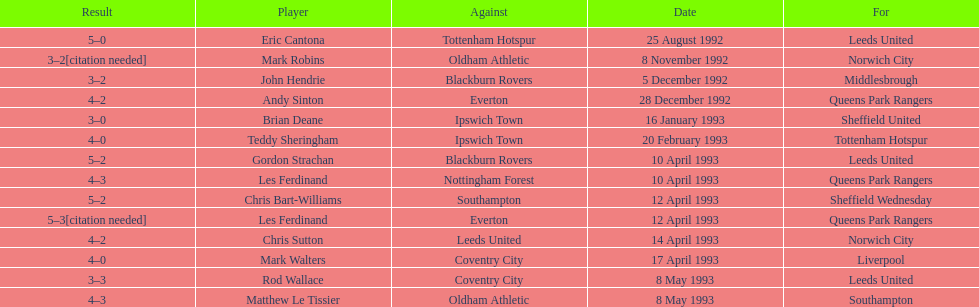Write the full table. {'header': ['Result', 'Player', 'Against', 'Date', 'For'], 'rows': [['5–0', 'Eric Cantona', 'Tottenham Hotspur', '25 August 1992', 'Leeds United'], ['3–2[citation needed]', 'Mark Robins', 'Oldham Athletic', '8 November 1992', 'Norwich City'], ['3–2', 'John Hendrie', 'Blackburn Rovers', '5 December 1992', 'Middlesbrough'], ['4–2', 'Andy Sinton', 'Everton', '28 December 1992', 'Queens Park Rangers'], ['3–0', 'Brian Deane', 'Ipswich Town', '16 January 1993', 'Sheffield United'], ['4–0', 'Teddy Sheringham', 'Ipswich Town', '20 February 1993', 'Tottenham Hotspur'], ['5–2', 'Gordon Strachan', 'Blackburn Rovers', '10 April 1993', 'Leeds United'], ['4–3', 'Les Ferdinand', 'Nottingham Forest', '10 April 1993', 'Queens Park Rangers'], ['5–2', 'Chris Bart-Williams', 'Southampton', '12 April 1993', 'Sheffield Wednesday'], ['5–3[citation needed]', 'Les Ferdinand', 'Everton', '12 April 1993', 'Queens Park Rangers'], ['4–2', 'Chris Sutton', 'Leeds United', '14 April 1993', 'Norwich City'], ['4–0', 'Mark Walters', 'Coventry City', '17 April 1993', 'Liverpool'], ['3–3', 'Rod Wallace', 'Coventry City', '8 May 1993', 'Leeds United'], ['4–3', 'Matthew Le Tissier', 'Oldham Athletic', '8 May 1993', 'Southampton']]} For which team does john hendrie play? Middlesbrough. 